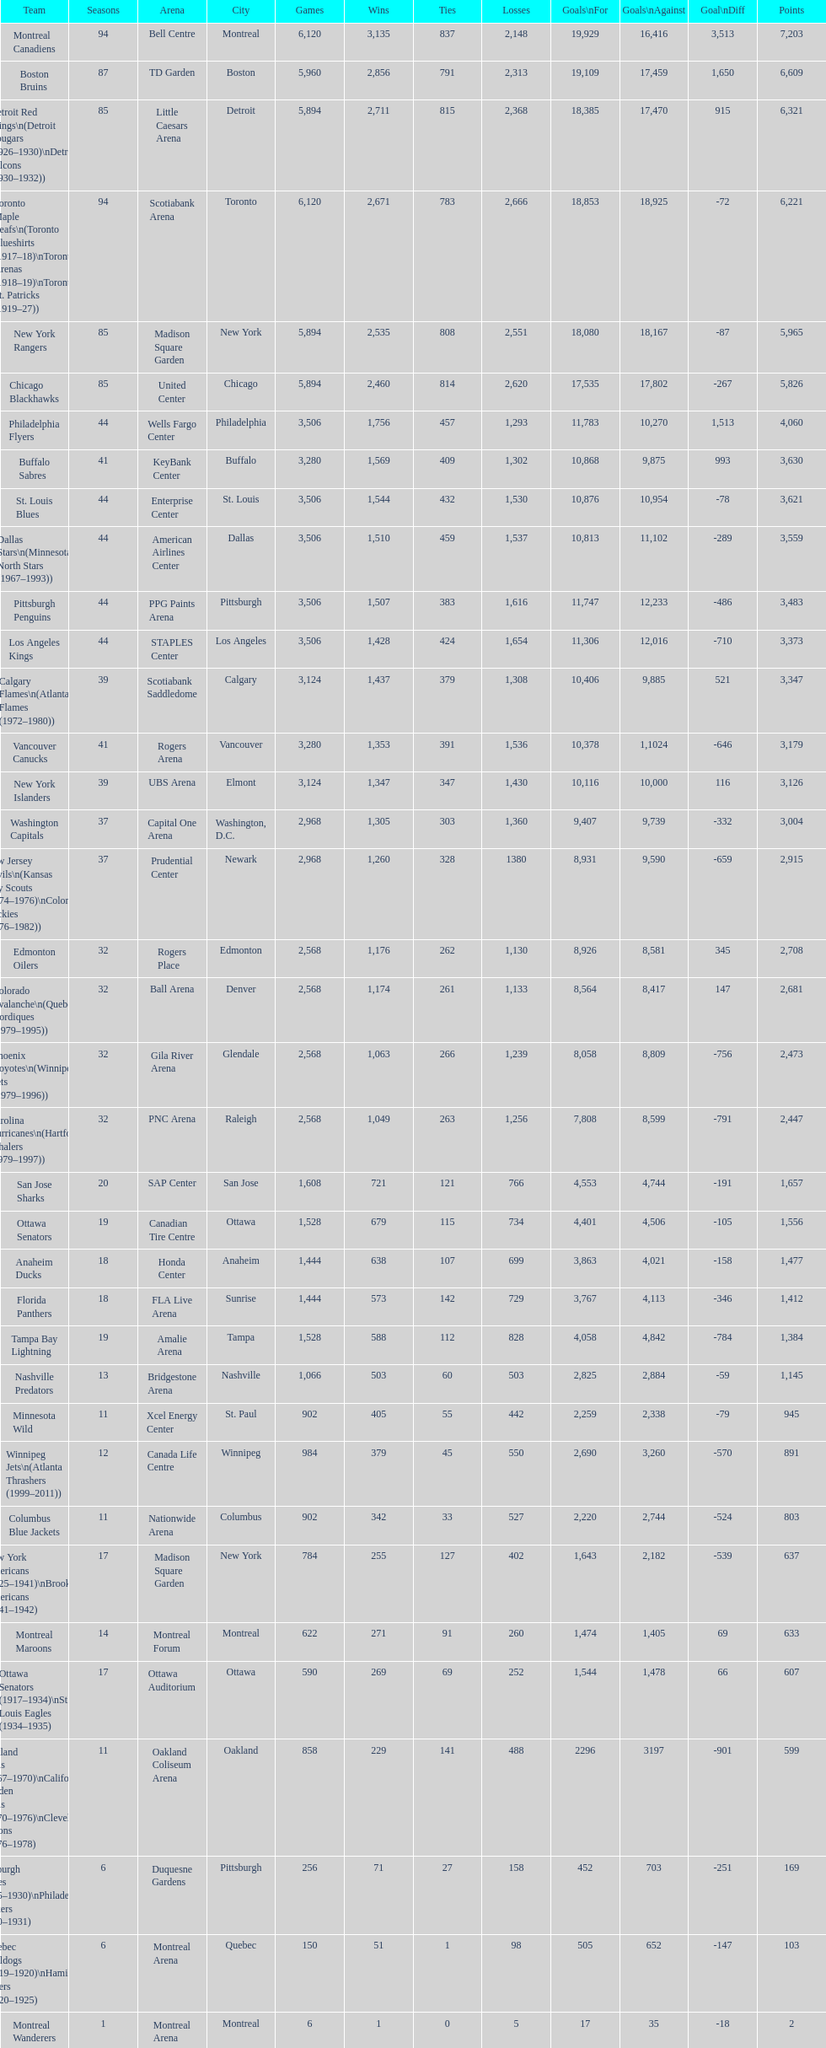Who has the least amount of losses? Montreal Wanderers. 